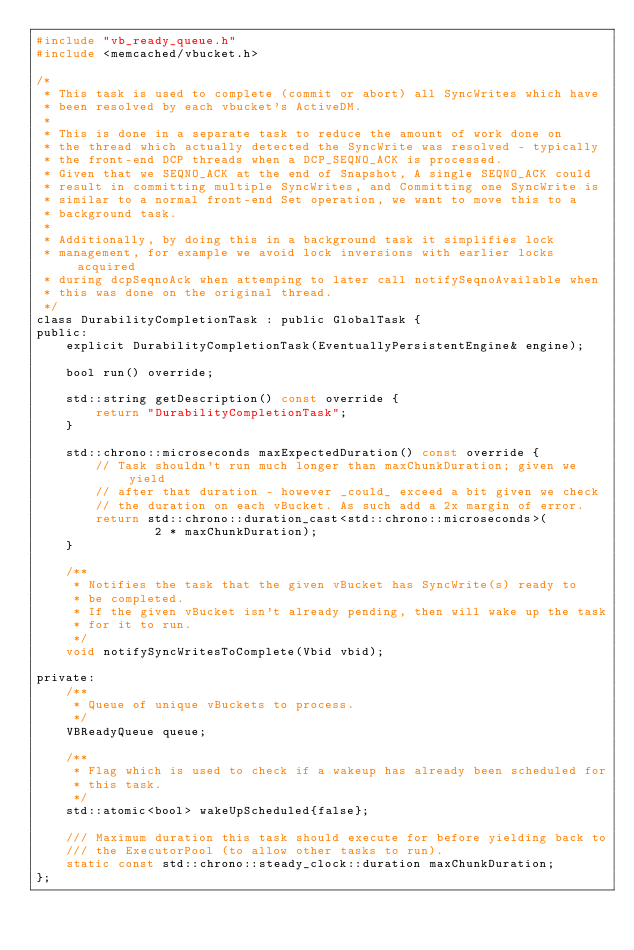Convert code to text. <code><loc_0><loc_0><loc_500><loc_500><_C_>#include "vb_ready_queue.h"
#include <memcached/vbucket.h>

/*
 * This task is used to complete (commit or abort) all SyncWrites which have
 * been resolved by each vbucket's ActiveDM.
 *
 * This is done in a separate task to reduce the amount of work done on
 * the thread which actually detected the SyncWrite was resolved - typically
 * the front-end DCP threads when a DCP_SEQNO_ACK is processed.
 * Given that we SEQNO_ACK at the end of Snapshot, A single SEQNO_ACK could
 * result in committing multiple SyncWrites, and Committing one SyncWrite is
 * similar to a normal front-end Set operation, we want to move this to a
 * background task.
 *
 * Additionally, by doing this in a background task it simplifies lock
 * management, for example we avoid lock inversions with earlier locks acquired
 * during dcpSeqnoAck when attemping to later call notifySeqnoAvailable when
 * this was done on the original thread.
 */
class DurabilityCompletionTask : public GlobalTask {
public:
    explicit DurabilityCompletionTask(EventuallyPersistentEngine& engine);

    bool run() override;

    std::string getDescription() const override {
        return "DurabilityCompletionTask";
    }

    std::chrono::microseconds maxExpectedDuration() const override {
        // Task shouldn't run much longer than maxChunkDuration; given we yield
        // after that duration - however _could_ exceed a bit given we check
        // the duration on each vBucket. As such add a 2x margin of error.
        return std::chrono::duration_cast<std::chrono::microseconds>(
                2 * maxChunkDuration);
    }

    /**
     * Notifies the task that the given vBucket has SyncWrite(s) ready to
     * be completed.
     * If the given vBucket isn't already pending, then will wake up the task
     * for it to run.
     */
    void notifySyncWritesToComplete(Vbid vbid);

private:
    /**
     * Queue of unique vBuckets to process.
     */
    VBReadyQueue queue;

    /**
     * Flag which is used to check if a wakeup has already been scheduled for
     * this task.
     */
    std::atomic<bool> wakeUpScheduled{false};

    /// Maximum duration this task should execute for before yielding back to
    /// the ExecutorPool (to allow other tasks to run).
    static const std::chrono::steady_clock::duration maxChunkDuration;
};
</code> 